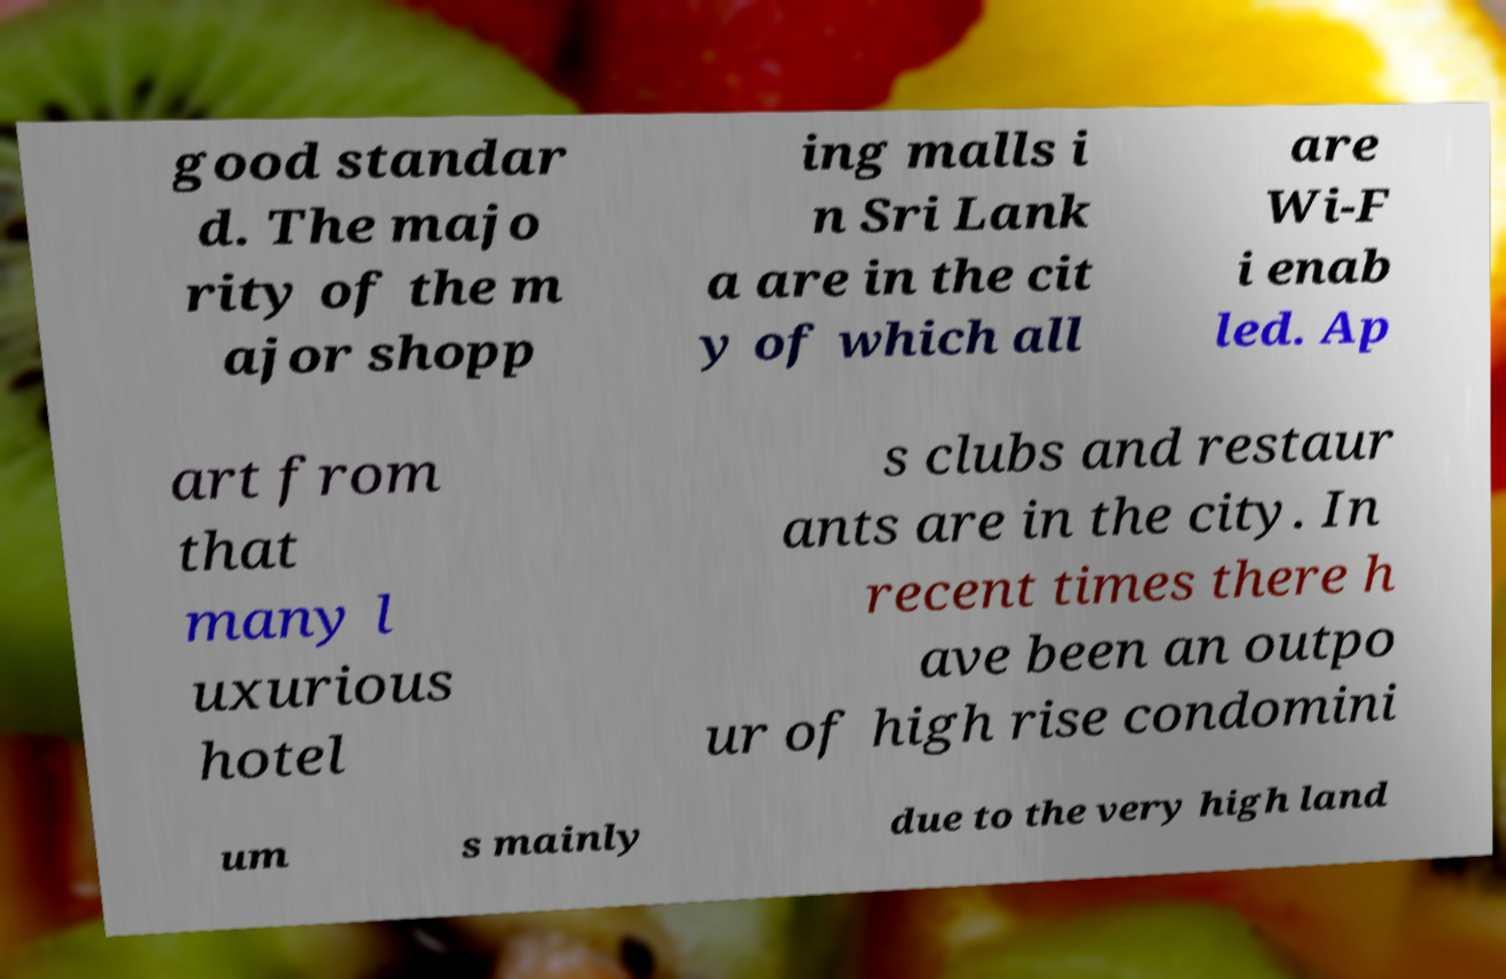Please identify and transcribe the text found in this image. good standar d. The majo rity of the m ajor shopp ing malls i n Sri Lank a are in the cit y of which all are Wi-F i enab led. Ap art from that many l uxurious hotel s clubs and restaur ants are in the city. In recent times there h ave been an outpo ur of high rise condomini um s mainly due to the very high land 